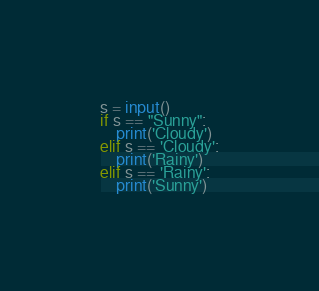Convert code to text. <code><loc_0><loc_0><loc_500><loc_500><_Python_>s = input()
if s == "Sunny":
    print('Cloudy')
elif s == 'Cloudy':
    print('Rainy')
elif s == 'Rainy':
    print('Sunny')</code> 